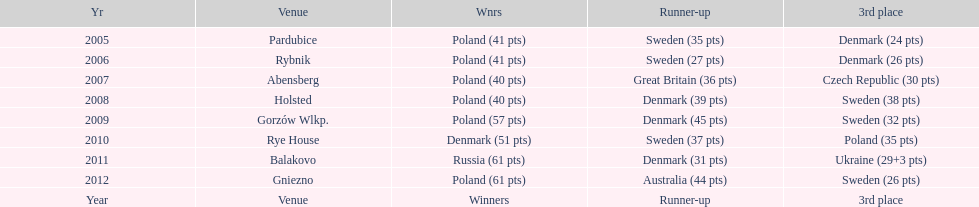From 2005-2012, in the team speedway junior world championship, how many more first place wins than all other teams put together? Poland. 